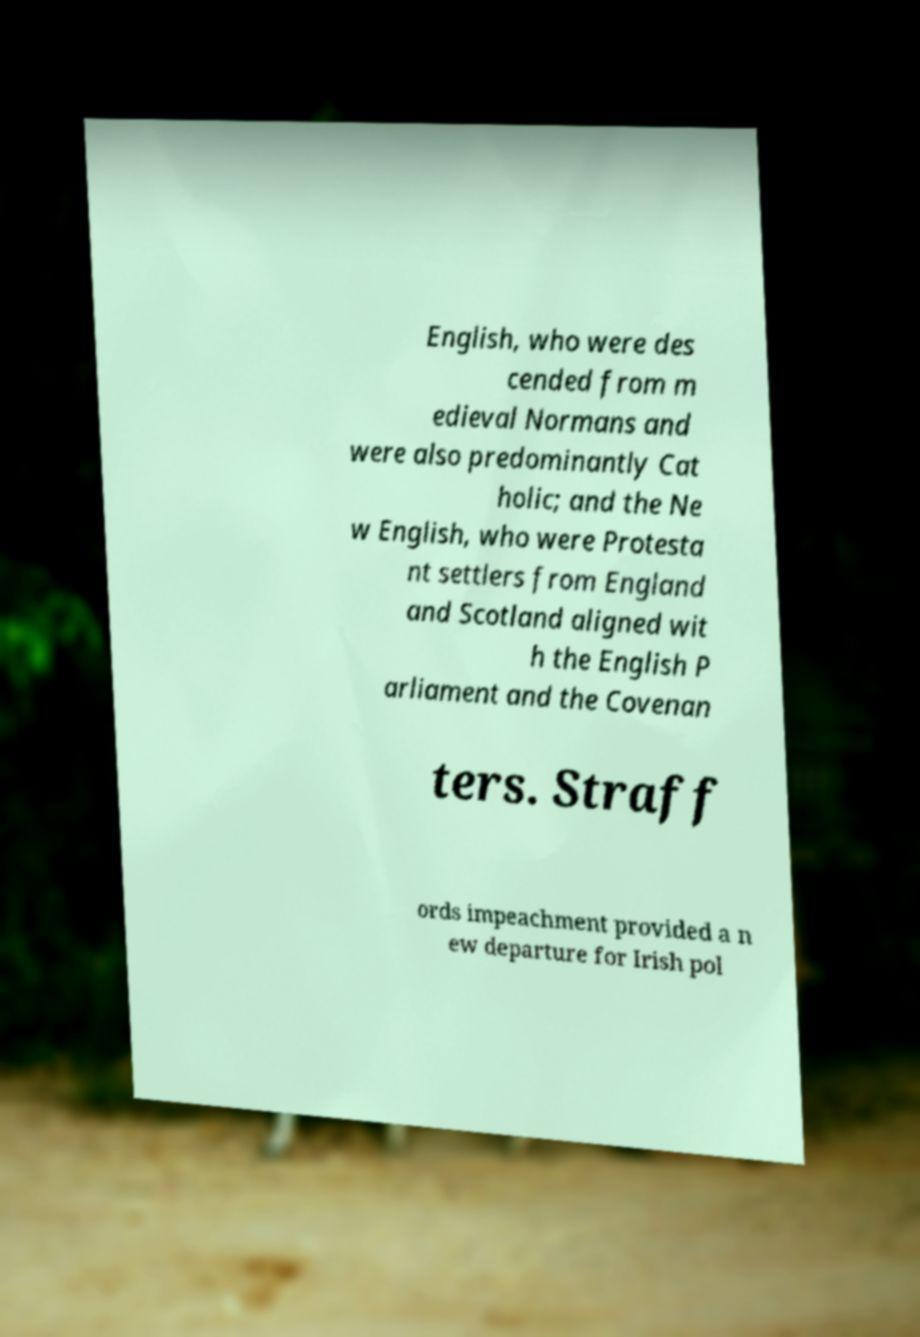Please identify and transcribe the text found in this image. English, who were des cended from m edieval Normans and were also predominantly Cat holic; and the Ne w English, who were Protesta nt settlers from England and Scotland aligned wit h the English P arliament and the Covenan ters. Straff ords impeachment provided a n ew departure for Irish pol 